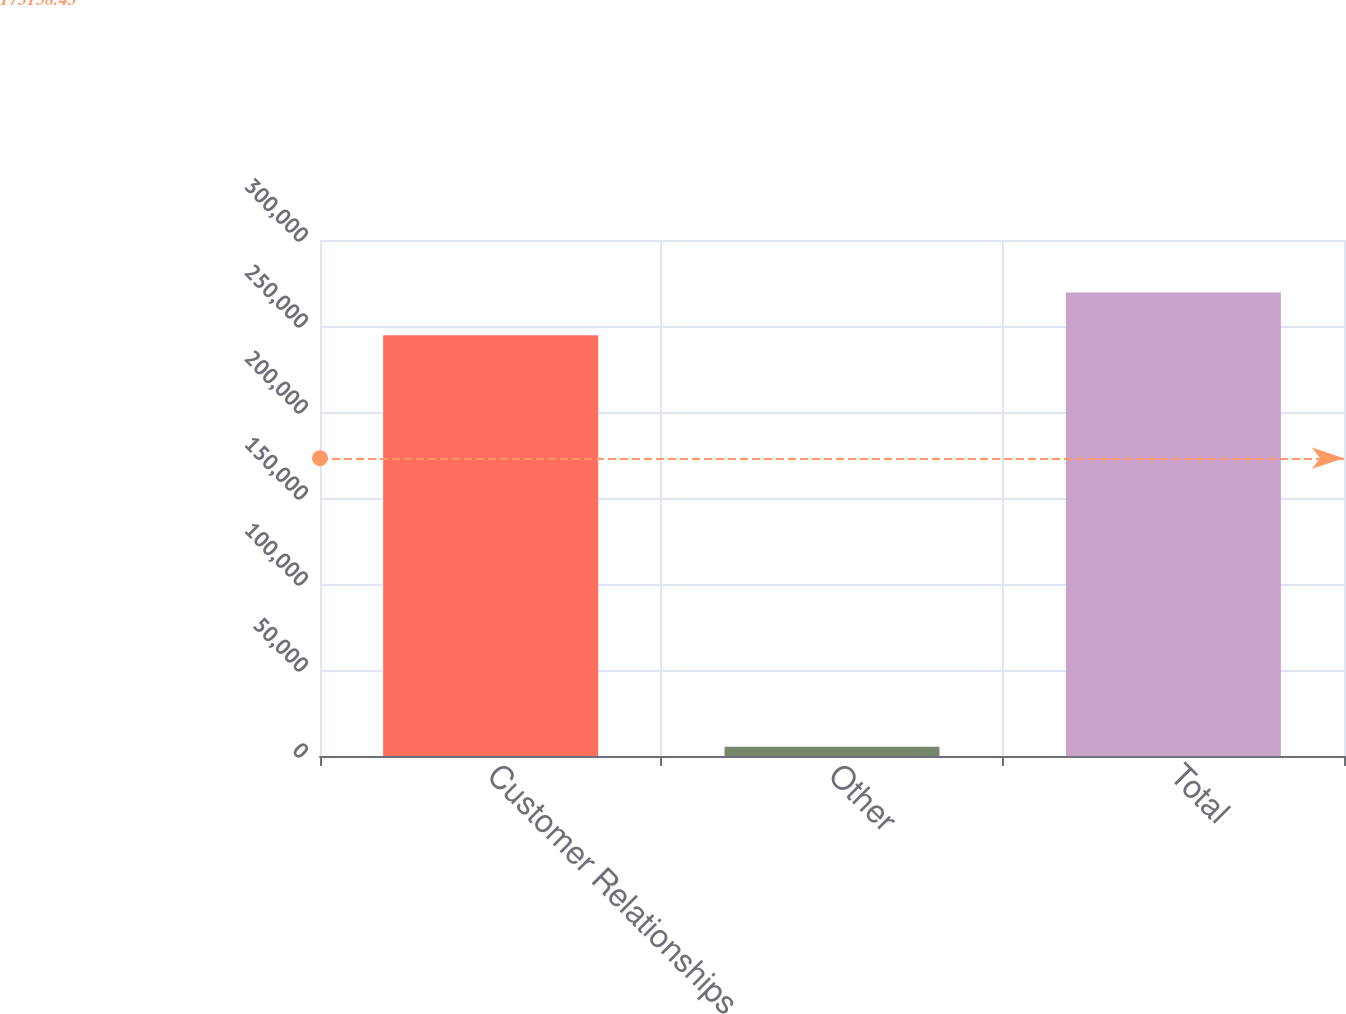Convert chart to OTSL. <chart><loc_0><loc_0><loc_500><loc_500><bar_chart><fcel>Customer Relationships<fcel>Other<fcel>Total<nl><fcel>244628<fcel>5307<fcel>269540<nl></chart> 